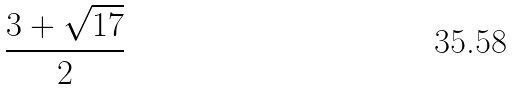<formula> <loc_0><loc_0><loc_500><loc_500>\frac { 3 + \sqrt { 1 7 } } { 2 }</formula> 